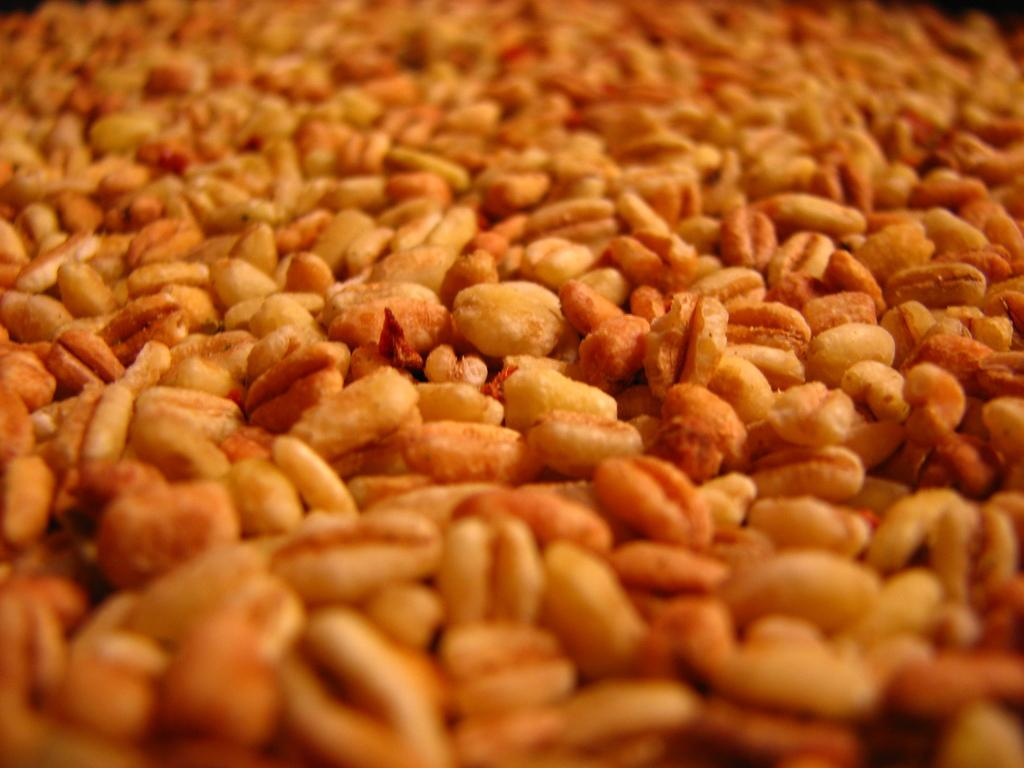What type of objects can be seen in the image? There are objects in the image that look like grains. What type of friends can be seen interacting with the grains in the image? There are no friends present in the image, as it only features objects that resemble grains. 